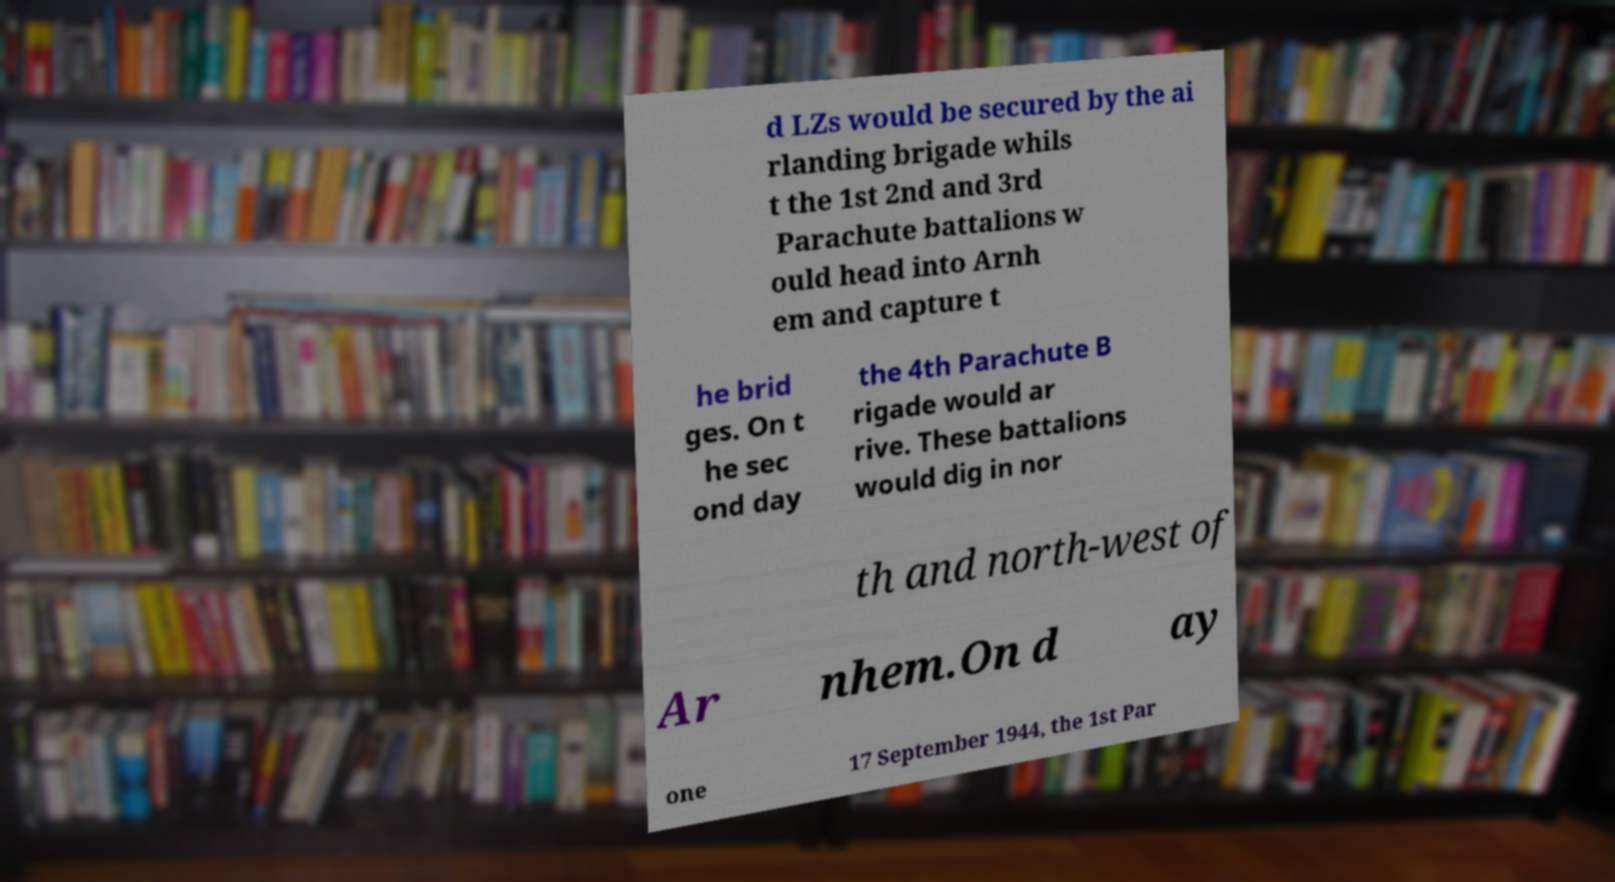Can you accurately transcribe the text from the provided image for me? d LZs would be secured by the ai rlanding brigade whils t the 1st 2nd and 3rd Parachute battalions w ould head into Arnh em and capture t he brid ges. On t he sec ond day the 4th Parachute B rigade would ar rive. These battalions would dig in nor th and north-west of Ar nhem.On d ay one 17 September 1944, the 1st Par 